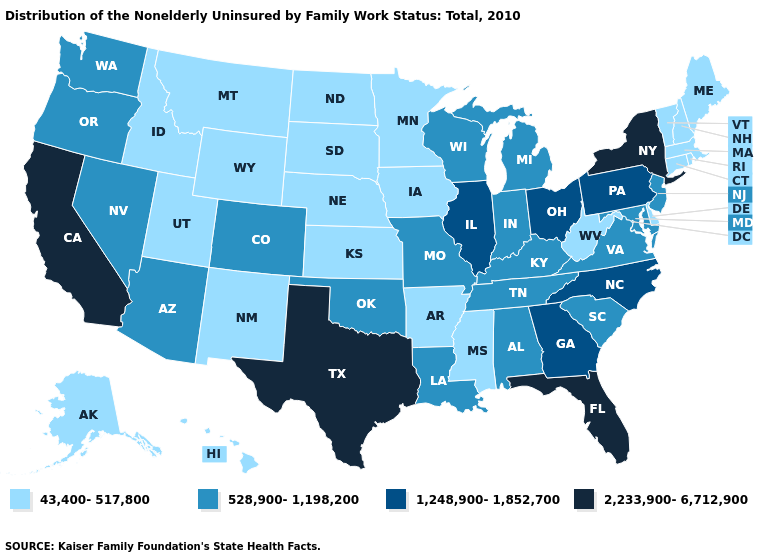Does California have the lowest value in the West?
Be succinct. No. Which states have the lowest value in the USA?
Concise answer only. Alaska, Arkansas, Connecticut, Delaware, Hawaii, Idaho, Iowa, Kansas, Maine, Massachusetts, Minnesota, Mississippi, Montana, Nebraska, New Hampshire, New Mexico, North Dakota, Rhode Island, South Dakota, Utah, Vermont, West Virginia, Wyoming. Name the states that have a value in the range 1,248,900-1,852,700?
Quick response, please. Georgia, Illinois, North Carolina, Ohio, Pennsylvania. Does the first symbol in the legend represent the smallest category?
Write a very short answer. Yes. Does Texas have the highest value in the USA?
Concise answer only. Yes. Name the states that have a value in the range 528,900-1,198,200?
Concise answer only. Alabama, Arizona, Colorado, Indiana, Kentucky, Louisiana, Maryland, Michigan, Missouri, Nevada, New Jersey, Oklahoma, Oregon, South Carolina, Tennessee, Virginia, Washington, Wisconsin. Does California have the highest value in the West?
Be succinct. Yes. Among the states that border Michigan , does Wisconsin have the highest value?
Short answer required. No. What is the highest value in the USA?
Quick response, please. 2,233,900-6,712,900. Among the states that border South Carolina , which have the highest value?
Keep it brief. Georgia, North Carolina. Among the states that border Nebraska , does Missouri have the highest value?
Concise answer only. Yes. What is the value of Illinois?
Quick response, please. 1,248,900-1,852,700. Does the map have missing data?
Write a very short answer. No. Which states have the highest value in the USA?
Write a very short answer. California, Florida, New York, Texas. Which states have the lowest value in the USA?
Concise answer only. Alaska, Arkansas, Connecticut, Delaware, Hawaii, Idaho, Iowa, Kansas, Maine, Massachusetts, Minnesota, Mississippi, Montana, Nebraska, New Hampshire, New Mexico, North Dakota, Rhode Island, South Dakota, Utah, Vermont, West Virginia, Wyoming. 